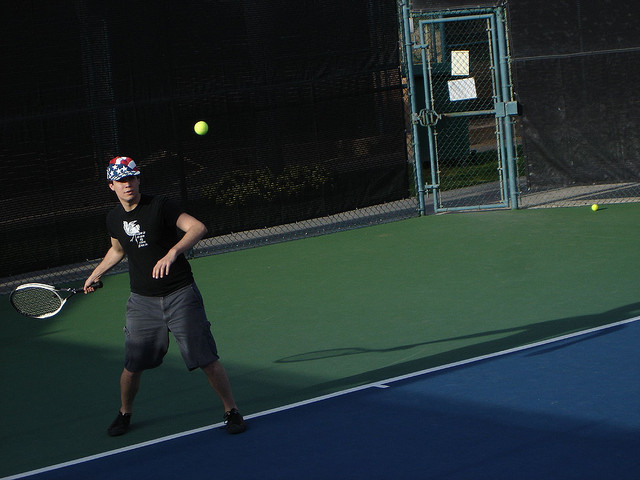<image>What clothing brand logo is seen here? It is ambiguous what clothing brand logo is seen here. Some suggestions include "Nike" or "Canadian", but it can also be unknown or not observed. What clothing brand logo is seen here? It is unclear what clothing brand logo is seen here. 